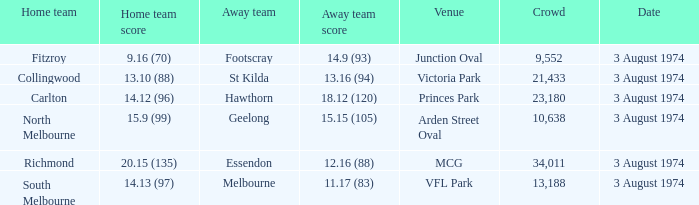Which home team possesses a venue of arden street oval? North Melbourne. Could you help me parse every detail presented in this table? {'header': ['Home team', 'Home team score', 'Away team', 'Away team score', 'Venue', 'Crowd', 'Date'], 'rows': [['Fitzroy', '9.16 (70)', 'Footscray', '14.9 (93)', 'Junction Oval', '9,552', '3 August 1974'], ['Collingwood', '13.10 (88)', 'St Kilda', '13.16 (94)', 'Victoria Park', '21,433', '3 August 1974'], ['Carlton', '14.12 (96)', 'Hawthorn', '18.12 (120)', 'Princes Park', '23,180', '3 August 1974'], ['North Melbourne', '15.9 (99)', 'Geelong', '15.15 (105)', 'Arden Street Oval', '10,638', '3 August 1974'], ['Richmond', '20.15 (135)', 'Essendon', '12.16 (88)', 'MCG', '34,011', '3 August 1974'], ['South Melbourne', '14.13 (97)', 'Melbourne', '11.17 (83)', 'VFL Park', '13,188', '3 August 1974']]} 